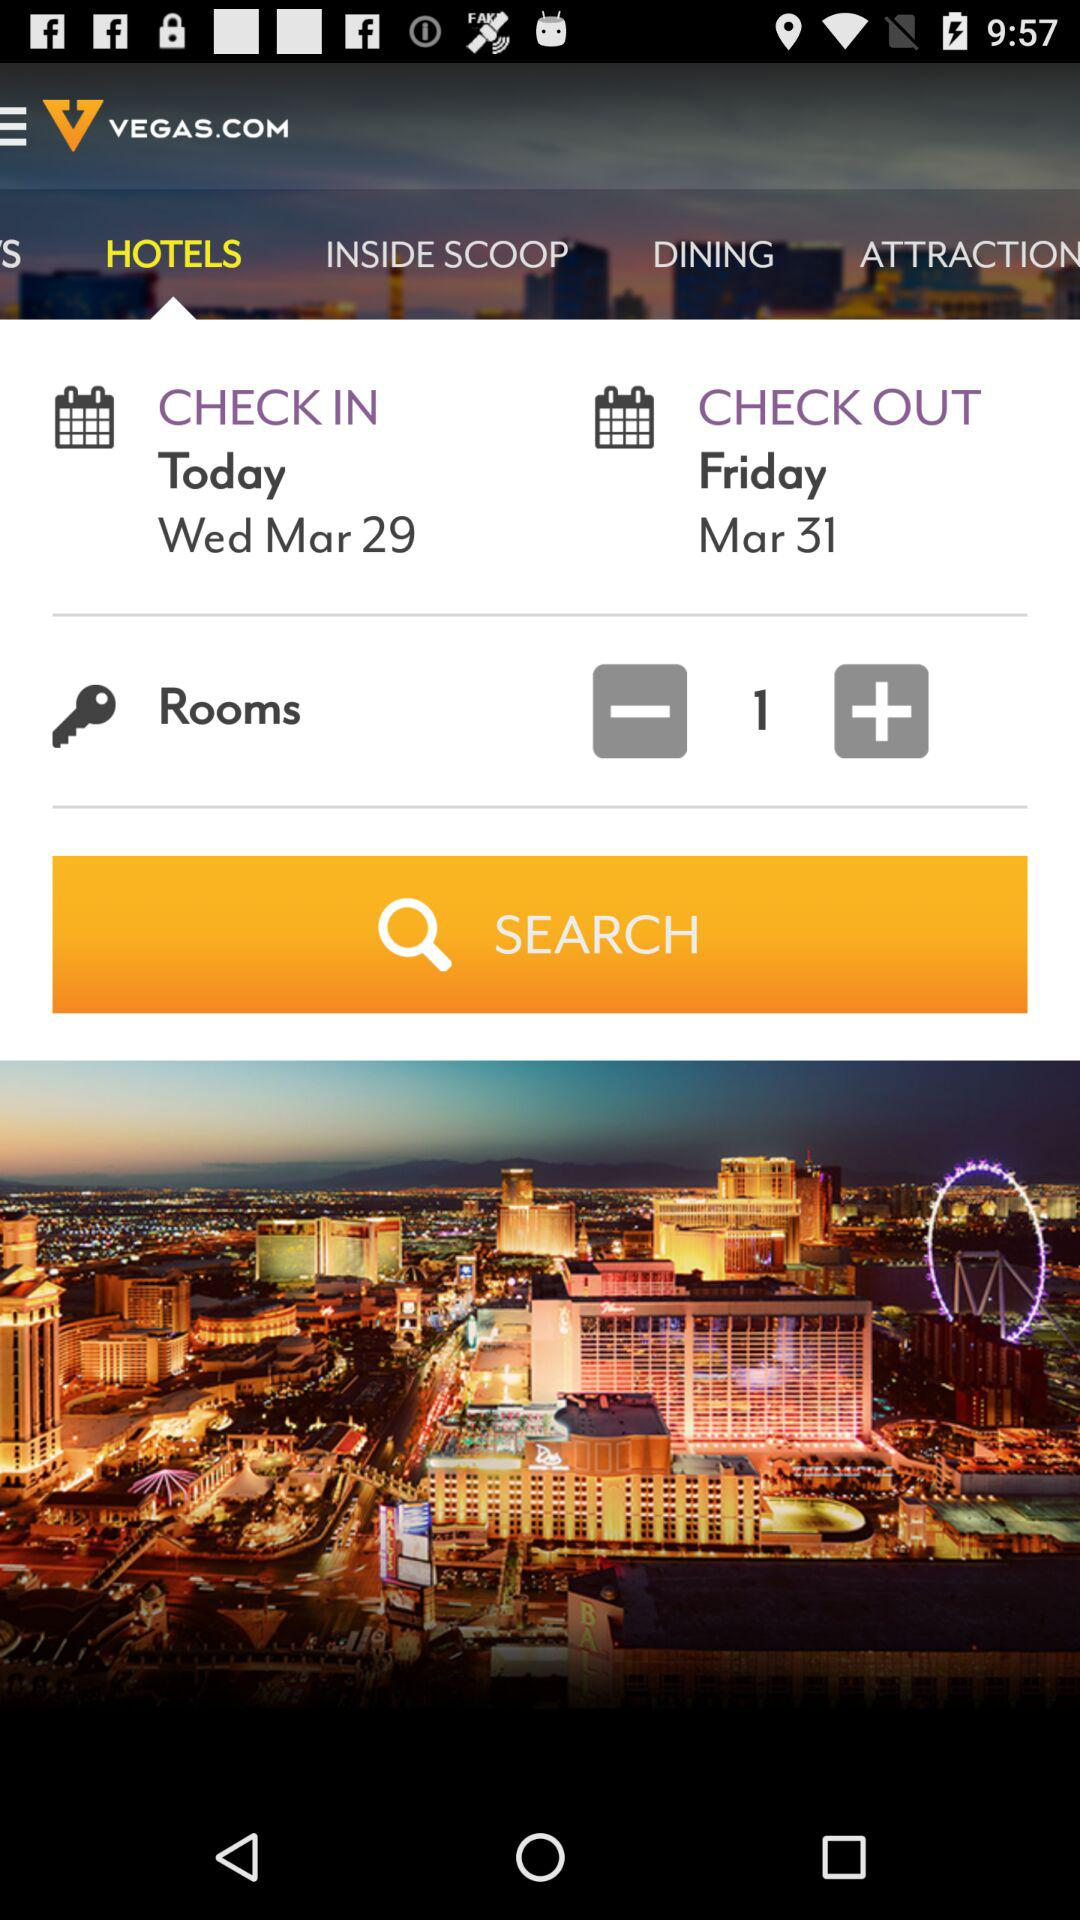How many guests are staying at the hotel?
When the provided information is insufficient, respond with <no answer>. <no answer> 